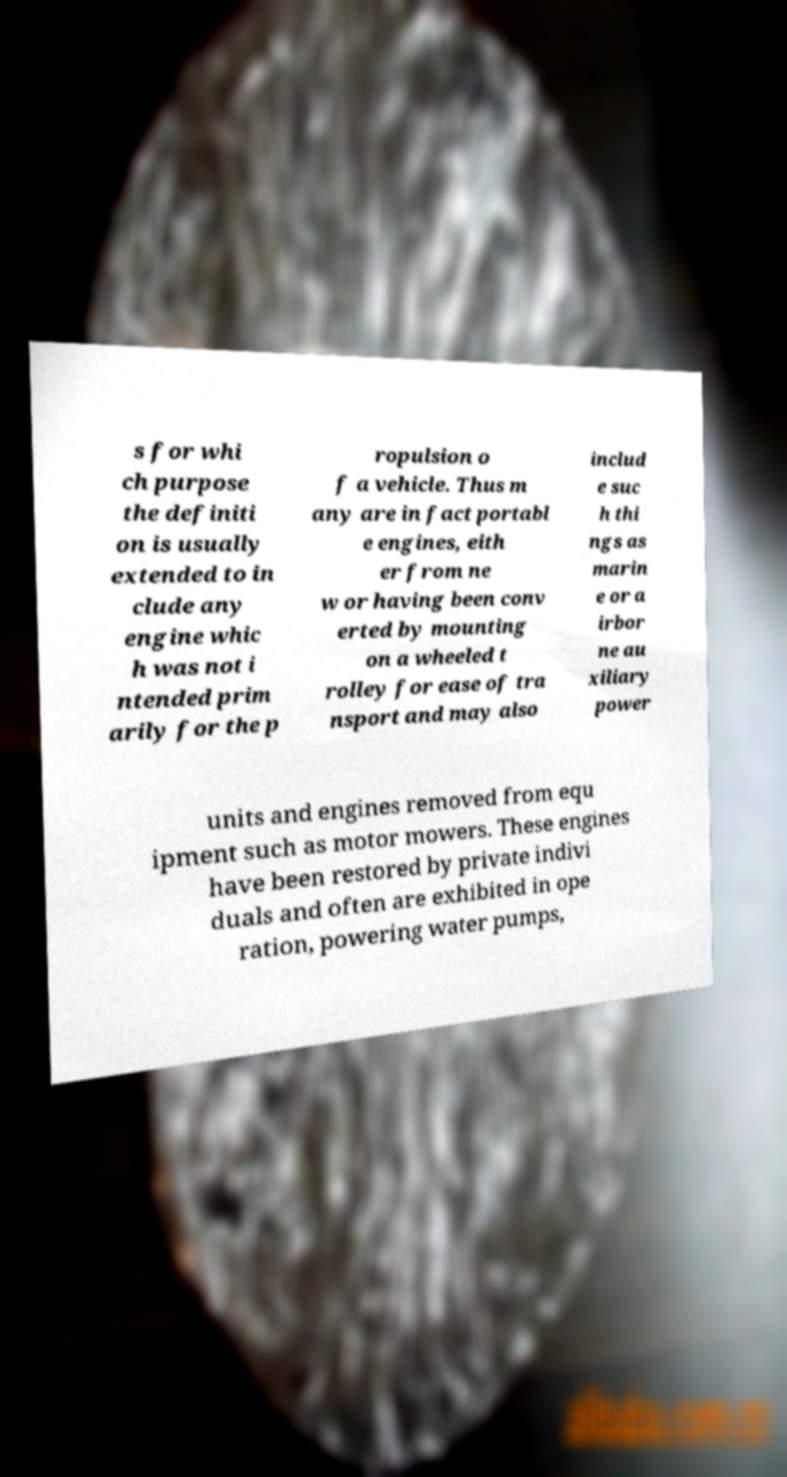What messages or text are displayed in this image? I need them in a readable, typed format. s for whi ch purpose the definiti on is usually extended to in clude any engine whic h was not i ntended prim arily for the p ropulsion o f a vehicle. Thus m any are in fact portabl e engines, eith er from ne w or having been conv erted by mounting on a wheeled t rolley for ease of tra nsport and may also includ e suc h thi ngs as marin e or a irbor ne au xiliary power units and engines removed from equ ipment such as motor mowers. These engines have been restored by private indivi duals and often are exhibited in ope ration, powering water pumps, 